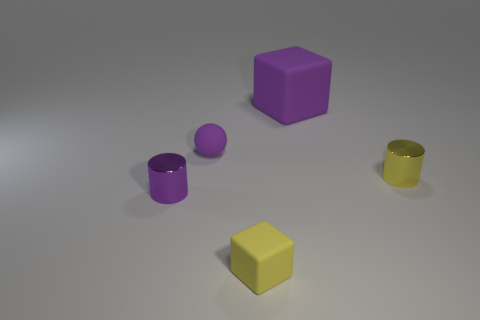What can you infer about the lighting source in this scene? The lighting in the scene seems to be coming from the upper left side, as indicated by the shadows cast to the right and slightly downwards on all objects. The softness of the shadows suggests the light source is not extremely close to the objects. 